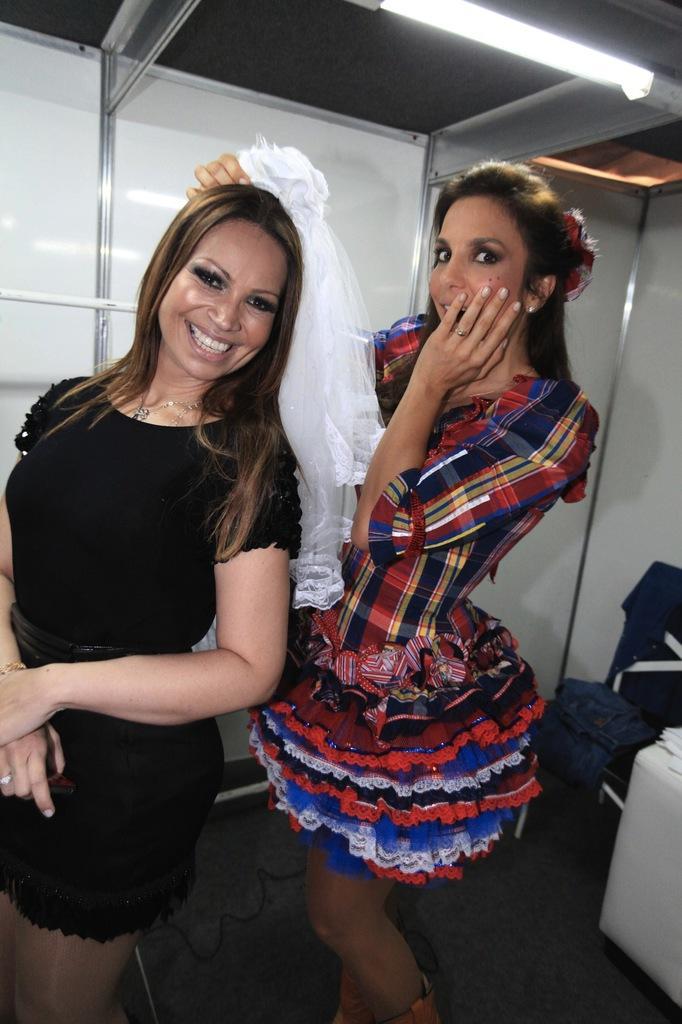How would you summarize this image in a sentence or two? In this picture we can see two women standing and smiling, chair with clothes on it, light and in the background we can see the wall. 